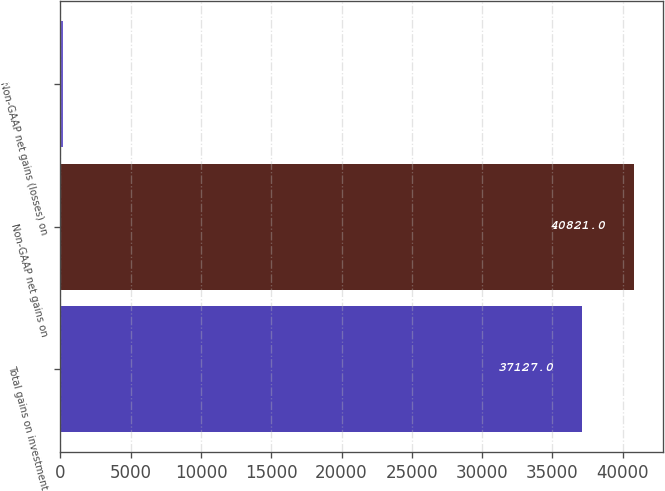Convert chart to OTSL. <chart><loc_0><loc_0><loc_500><loc_500><bar_chart><fcel>Total gains on investment<fcel>Non-GAAP net gains on<fcel>Non-GAAP net gains (losses) on<nl><fcel>37127<fcel>40821<fcel>187<nl></chart> 